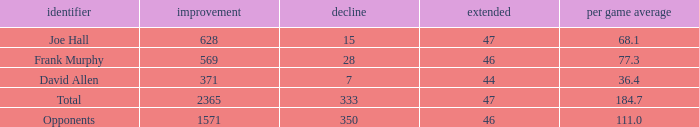Which Avg/G is the lowest one that has a Long smaller than 47, and a Name of frank murphy, and a Gain smaller than 569? None. 